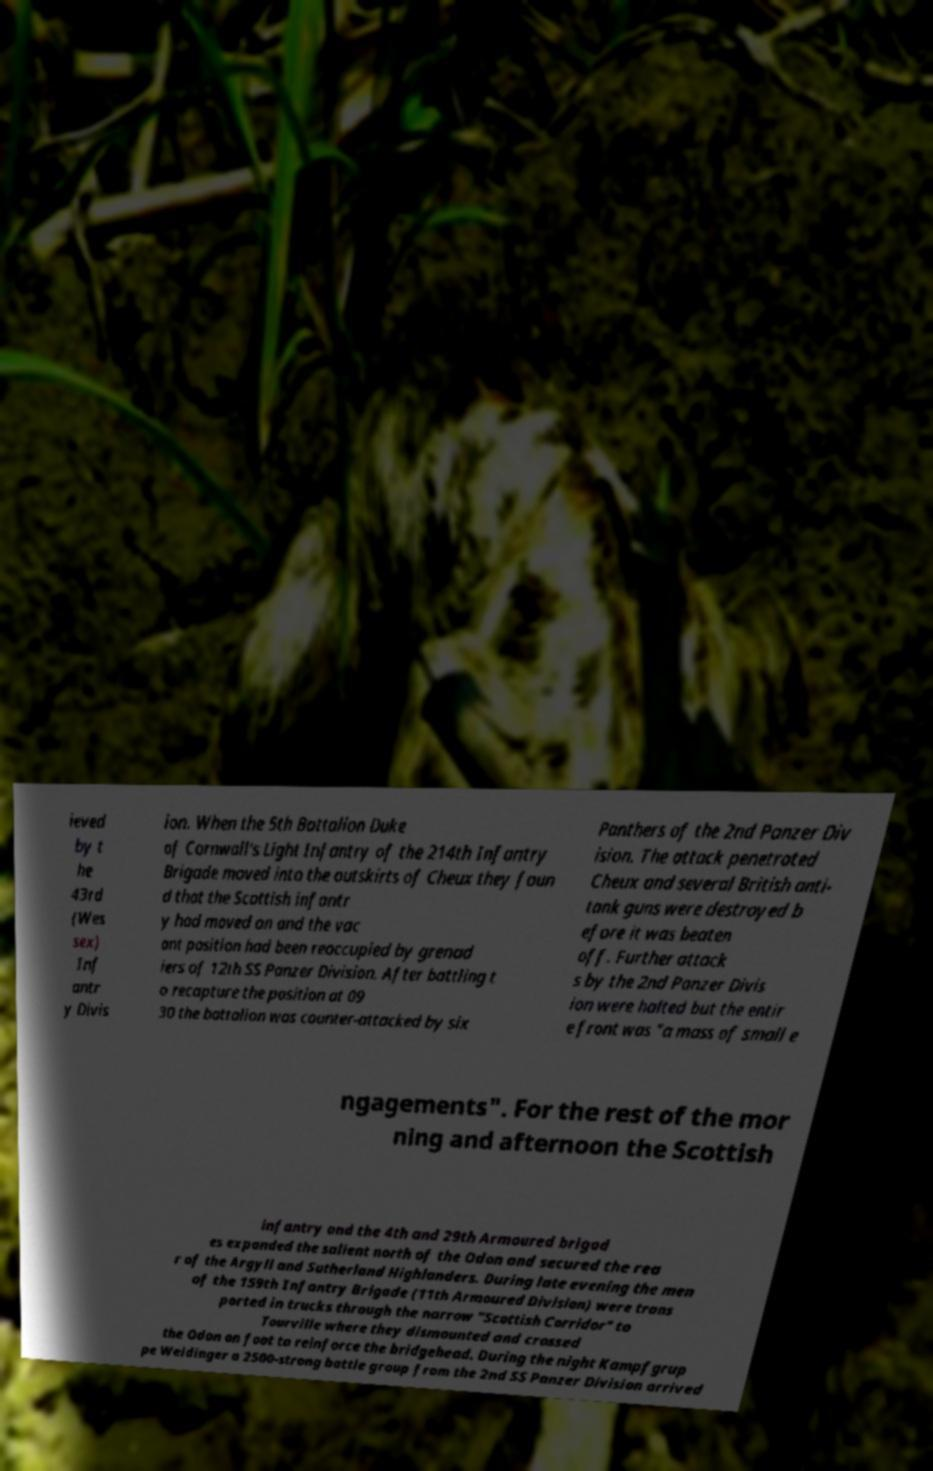Could you assist in decoding the text presented in this image and type it out clearly? ieved by t he 43rd (Wes sex) Inf antr y Divis ion. When the 5th Battalion Duke of Cornwall's Light Infantry of the 214th Infantry Brigade moved into the outskirts of Cheux they foun d that the Scottish infantr y had moved on and the vac ant position had been reoccupied by grenad iers of 12th SS Panzer Division. After battling t o recapture the position at 09 30 the battalion was counter-attacked by six Panthers of the 2nd Panzer Div ision. The attack penetrated Cheux and several British anti- tank guns were destroyed b efore it was beaten off. Further attack s by the 2nd Panzer Divis ion were halted but the entir e front was "a mass of small e ngagements". For the rest of the mor ning and afternoon the Scottish infantry and the 4th and 29th Armoured brigad es expanded the salient north of the Odon and secured the rea r of the Argyll and Sutherland Highlanders. During late evening the men of the 159th Infantry Brigade (11th Armoured Division) were trans ported in trucks through the narrow "Scottish Corridor" to Tourville where they dismounted and crossed the Odon on foot to reinforce the bridgehead. During the night Kampfgrup pe Weidinger a 2500-strong battle group from the 2nd SS Panzer Division arrived 